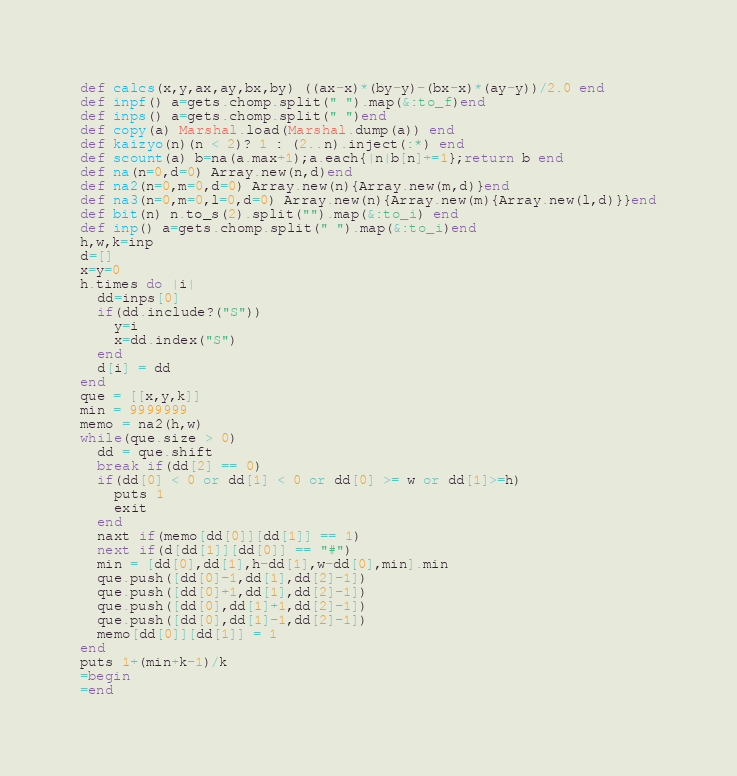Convert code to text. <code><loc_0><loc_0><loc_500><loc_500><_Ruby_>def calcs(x,y,ax,ay,bx,by) ((ax-x)*(by-y)-(bx-x)*(ay-y))/2.0 end
def inpf() a=gets.chomp.split(" ").map(&:to_f)end
def inps() a=gets.chomp.split(" ")end  
def copy(a) Marshal.load(Marshal.dump(a)) end
def kaizyo(n)(n < 2)? 1 : (2..n).inject(:*) end
def scount(a) b=na(a.max+1);a.each{|n|b[n]+=1};return b end
def na(n=0,d=0) Array.new(n,d)end
def na2(n=0,m=0,d=0) Array.new(n){Array.new(m,d)}end
def na3(n=0,m=0,l=0,d=0) Array.new(n){Array.new(m){Array.new(l,d)}}end
def bit(n) n.to_s(2).split("").map(&:to_i) end
def inp() a=gets.chomp.split(" ").map(&:to_i)end
h,w,k=inp
d=[]
x=y=0
h.times do |i|
  dd=inps[0]
  if(dd.include?("S"))
    y=i
    x=dd.index("S")
  end
  d[i] = dd
end
que = [[x,y,k]]
min = 9999999
memo = na2(h,w)
while(que.size > 0)
  dd = que.shift
  break if(dd[2] == 0)
  if(dd[0] < 0 or dd[1] < 0 or dd[0] >= w or dd[1]>=h)
    puts 1
    exit
  end
  naxt if(memo[dd[0]][dd[1]] == 1)
  next if(d[dd[1]][dd[0]] == "#")
  min = [dd[0],dd[1],h-dd[1],w-dd[0],min].min
  que.push([dd[0]-1,dd[1],dd[2]-1])
  que.push([dd[0]+1,dd[1],dd[2]-1])
  que.push([dd[0],dd[1]+1,dd[2]-1])
  que.push([dd[0],dd[1]-1,dd[2]-1])
  memo[dd[0]][dd[1]] = 1
end
puts 1+(min+k-1)/k
=begin
=end</code> 